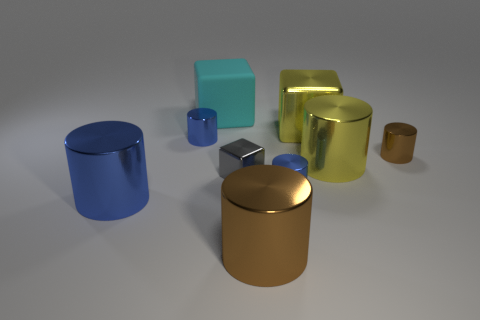Add 1 yellow cylinders. How many objects exist? 10 Subtract all large yellow cylinders. How many cylinders are left? 5 Subtract all yellow cylinders. How many cylinders are left? 5 Subtract 5 cylinders. How many cylinders are left? 1 Subtract all cylinders. How many objects are left? 3 Subtract all gray cylinders. Subtract all cyan spheres. How many cylinders are left? 6 Subtract all cyan cylinders. How many blue blocks are left? 0 Subtract all tiny brown balls. Subtract all cyan blocks. How many objects are left? 8 Add 7 big metal blocks. How many big metal blocks are left? 8 Add 7 large brown metallic cylinders. How many large brown metallic cylinders exist? 8 